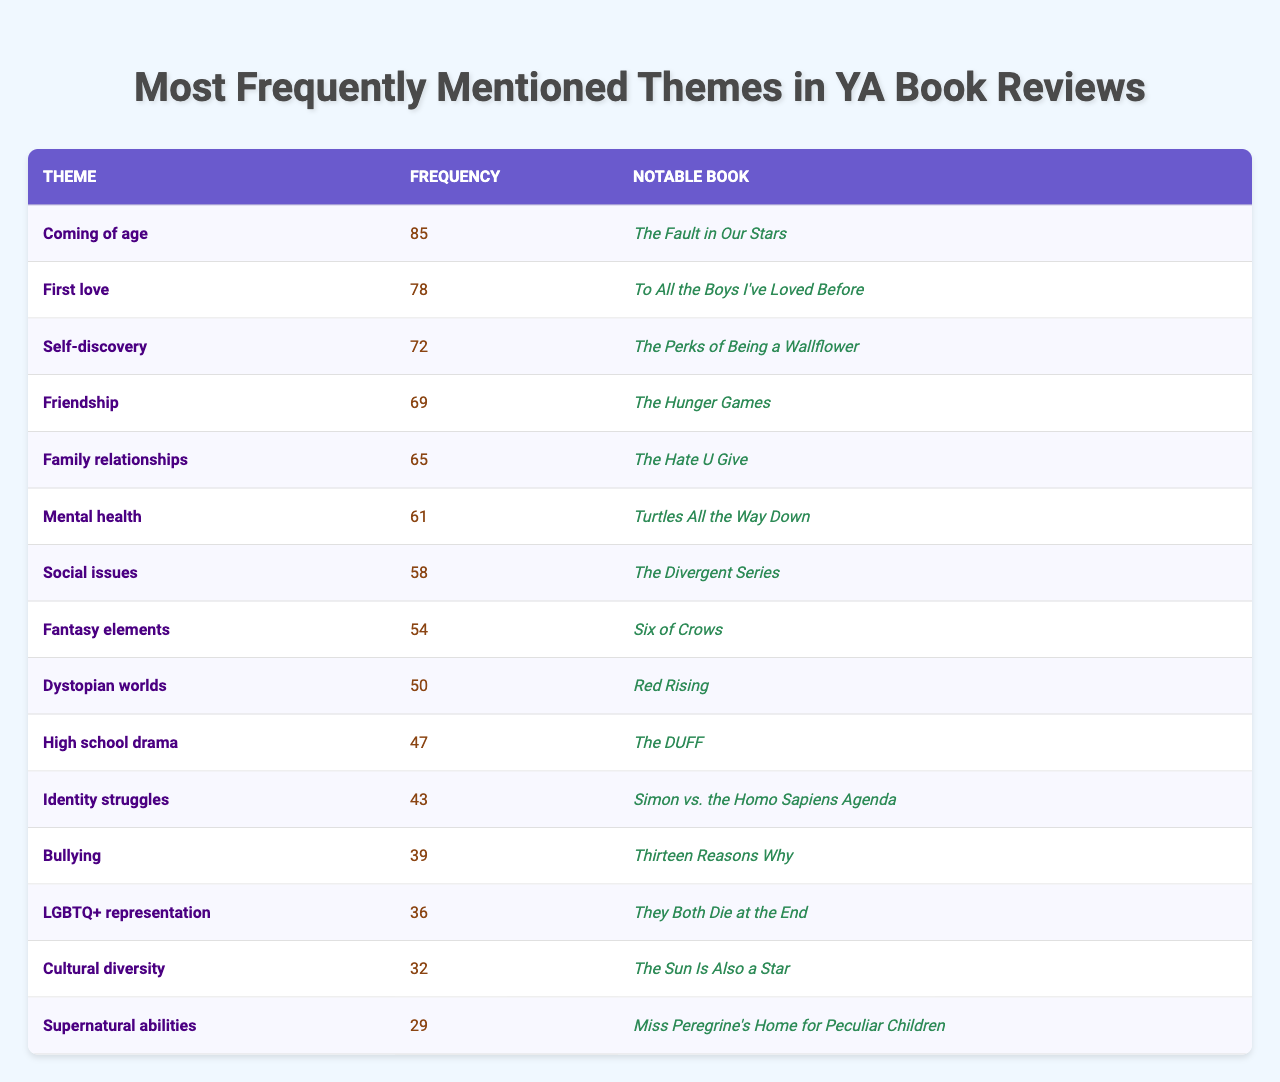What is the most frequently mentioned theme in YA book reviews? The theme with the highest frequency in the table is "Coming of age," which has a frequency of 85 mentions.
Answer: Coming of age Which theme is mentioned the least in YA book reviews? The theme with the lowest frequency in the table is "Supernatural abilities," with a frequency of 29 mentions.
Answer: Supernatural abilities Are "Friendship" and "Family relationships" mentioned with equal frequency? "Friendship" has a frequency of 69, while "Family relationships" has a frequency of 65. They are not mentioned with equal frequency, as "Friendship" is mentioned more.
Answer: No Which notable book corresponds to the theme of "Mental health"? The theme "Mental health" corresponds to the notable book "Turtles All the Way Down."
Answer: Turtles All the Way Down What is the frequency difference between "Identity struggles" and "Social issues"? "Identity struggles" has a frequency of 43 and "Social issues" has a frequency of 58. The difference is 58 - 43 = 15.
Answer: 15 What theme has a frequency of 50? The theme with a frequency of 50 is "Dystopian worlds."
Answer: Dystopian worlds If you were to rank the themes by their frequency, how many themes would be in the top three? The top three themes by frequency are "Coming of age," "First love," and "Self-discovery," making a total of three themes in the top three.
Answer: Three What is the average frequency of the themes listed? The total frequency is 85 + 78 + 72 + 69 + 65 + 61 + 58 + 54 + 50 + 47 + 43 + 39 + 36 + 32 + 29 =  743. There are 15 themes, so the average frequency is 743 / 15 = 49.53.
Answer: 49.53 Which two themes are mentioned with frequencies closest to each other? "Thirteen Reasons Why" associated with "Bullying" has a frequency of 39, while "Simon vs. the Homo Sapiens Agenda" associated with "LGBTQ+ representation" has a frequency of 36. The frequencies of these themes are closest together.
Answer: Bullying and LGBTQ+ representation Is "The Hate U Give" related to issues of family relationships in its narrative? "The Hate U Give" is primarily about social issues, as indicated in the notable books for that theme. It does not focus specifically on family relationships.
Answer: No 